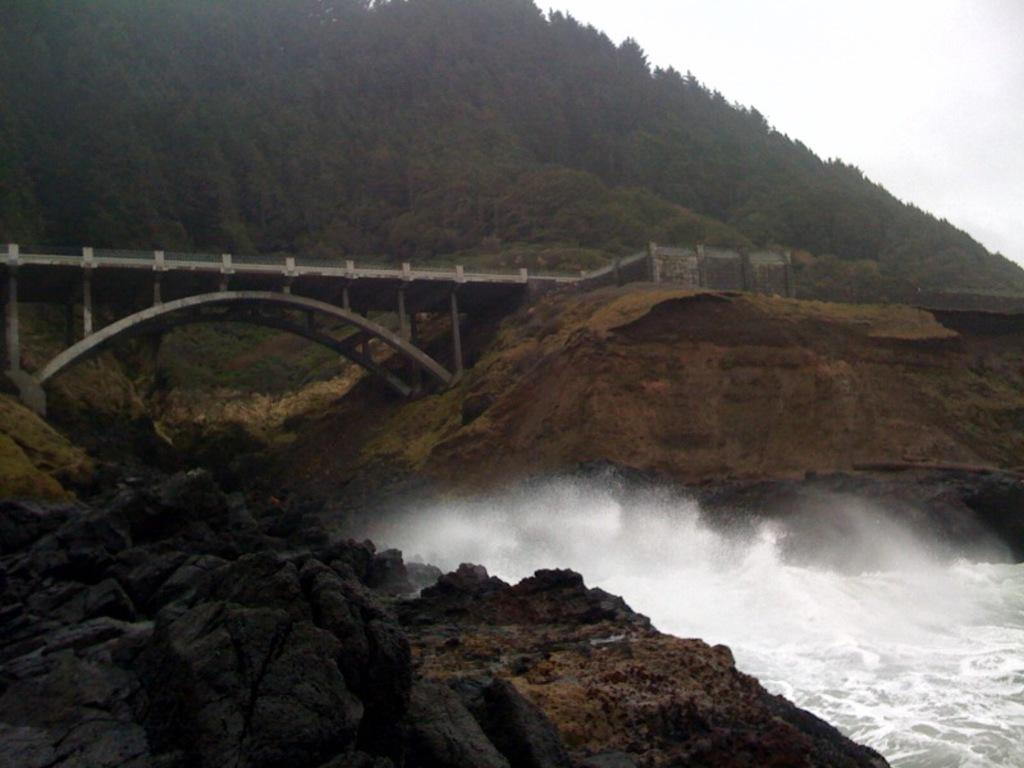What type of structure can be seen in the image? There is a bridge in the image. What natural features are present in the background of the image? There are trees on a mountain in the image. What type of terrain is visible in the foreground of the image? There are rocks in the foreground of the image. What is visible at the top of the image? The sky is visible at the top of the image. What type of body of water is present in the image? There is water visible at the bottom of the image. What type of brass instrument is being played in the image? There is no brass instrument or any indication of music being played in the image. 